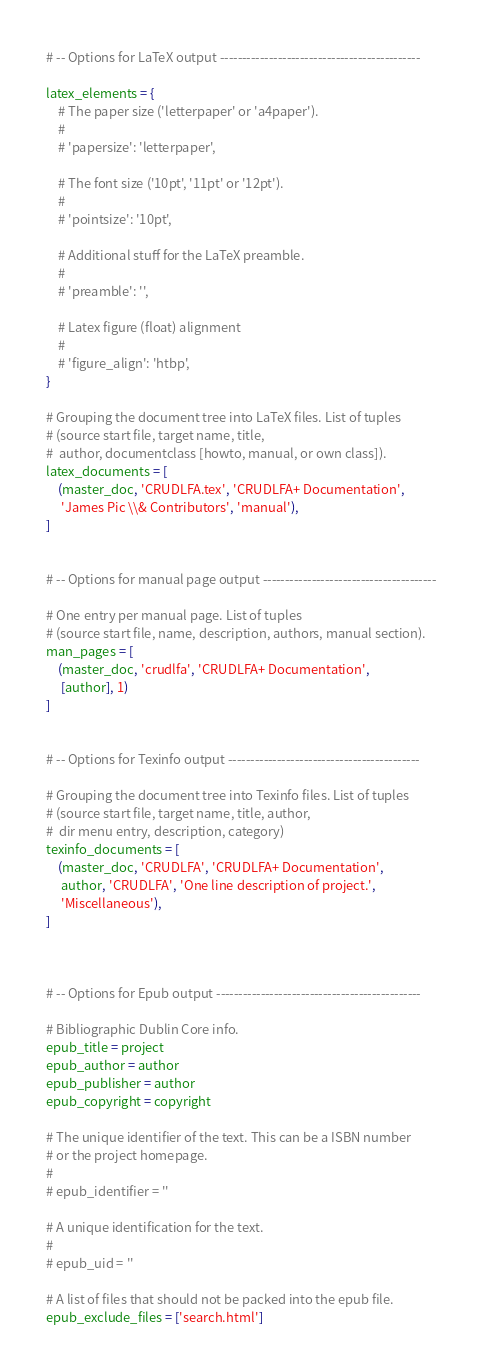<code> <loc_0><loc_0><loc_500><loc_500><_Python_>
# -- Options for LaTeX output ---------------------------------------------

latex_elements = {
    # The paper size ('letterpaper' or 'a4paper').
    #
    # 'papersize': 'letterpaper',

    # The font size ('10pt', '11pt' or '12pt').
    #
    # 'pointsize': '10pt',

    # Additional stuff for the LaTeX preamble.
    #
    # 'preamble': '',

    # Latex figure (float) alignment
    #
    # 'figure_align': 'htbp',
}

# Grouping the document tree into LaTeX files. List of tuples
# (source start file, target name, title,
#  author, documentclass [howto, manual, or own class]).
latex_documents = [
    (master_doc, 'CRUDLFA.tex', 'CRUDLFA+ Documentation',
     'James Pic \\& Contributors', 'manual'),
]


# -- Options for manual page output ---------------------------------------

# One entry per manual page. List of tuples
# (source start file, name, description, authors, manual section).
man_pages = [
    (master_doc, 'crudlfa', 'CRUDLFA+ Documentation',
     [author], 1)
]


# -- Options for Texinfo output -------------------------------------------

# Grouping the document tree into Texinfo files. List of tuples
# (source start file, target name, title, author,
#  dir menu entry, description, category)
texinfo_documents = [
    (master_doc, 'CRUDLFA', 'CRUDLFA+ Documentation',
     author, 'CRUDLFA', 'One line description of project.',
     'Miscellaneous'),
]



# -- Options for Epub output ----------------------------------------------

# Bibliographic Dublin Core info.
epub_title = project
epub_author = author
epub_publisher = author
epub_copyright = copyright

# The unique identifier of the text. This can be a ISBN number
# or the project homepage.
#
# epub_identifier = ''

# A unique identification for the text.
#
# epub_uid = ''

# A list of files that should not be packed into the epub file.
epub_exclude_files = ['search.html']


</code> 